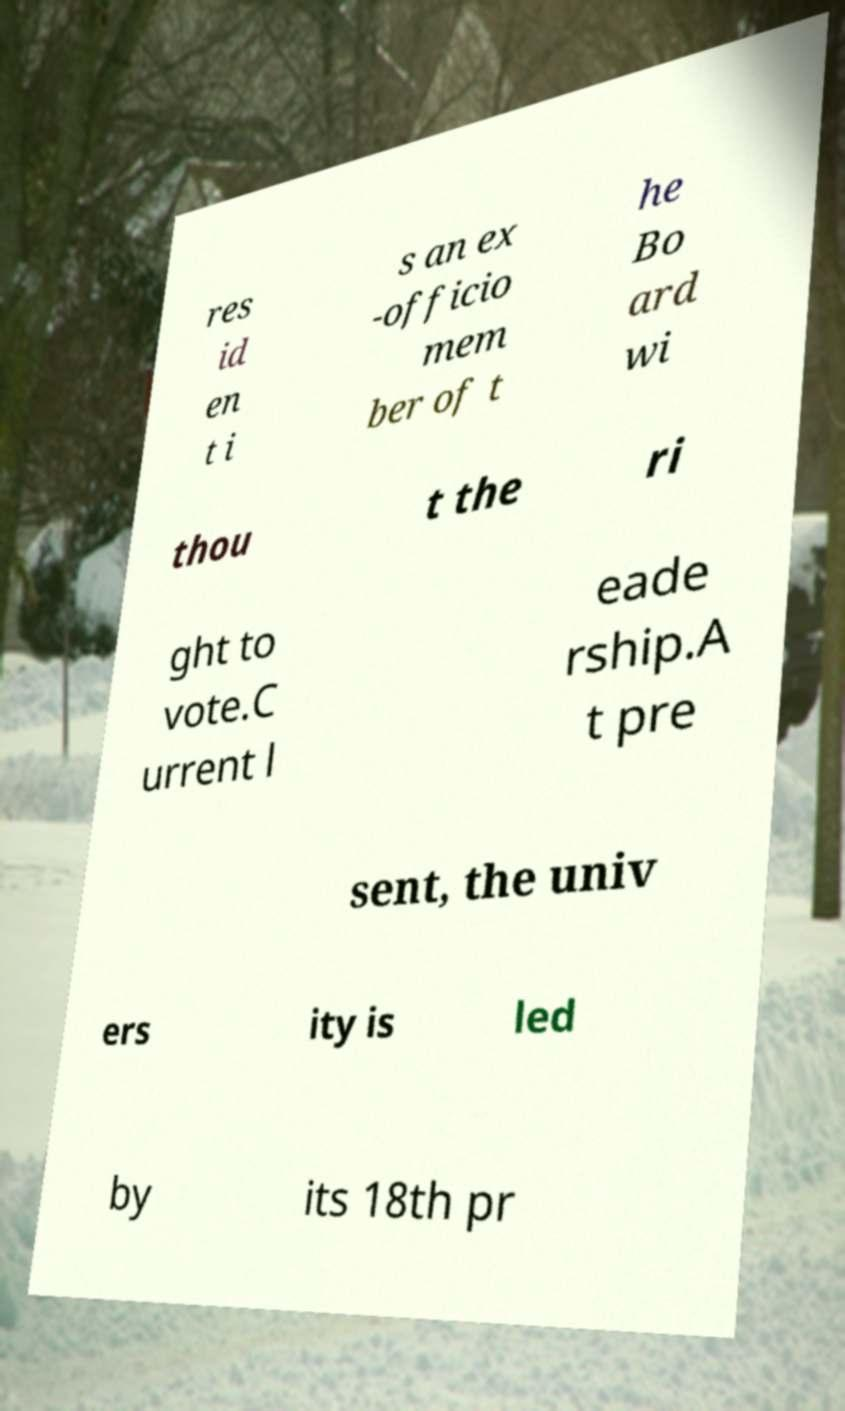For documentation purposes, I need the text within this image transcribed. Could you provide that? res id en t i s an ex -officio mem ber of t he Bo ard wi thou t the ri ght to vote.C urrent l eade rship.A t pre sent, the univ ers ity is led by its 18th pr 